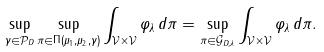Convert formula to latex. <formula><loc_0><loc_0><loc_500><loc_500>\sup _ { \gamma \in \mathcal { P } _ { D } } \sup _ { \pi \in \Pi \left ( \mu _ { 1 } , \mu _ { 2 } , \gamma \right ) } \int _ { \mathcal { V } \times \mathcal { V } } \varphi _ { \lambda } \, d \pi = \sup _ { \pi \in \mathcal { G } _ { D , \lambda } } \int _ { \mathcal { V } \times \mathcal { V } } \varphi _ { \lambda } \, d \pi .</formula> 